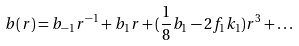<formula> <loc_0><loc_0><loc_500><loc_500>b ( r ) = b _ { - 1 } r ^ { - 1 } + b _ { 1 } r + ( \frac { 1 } { 8 } b _ { 1 } - 2 f _ { 1 } k _ { 1 } ) r ^ { 3 } + \dots</formula> 